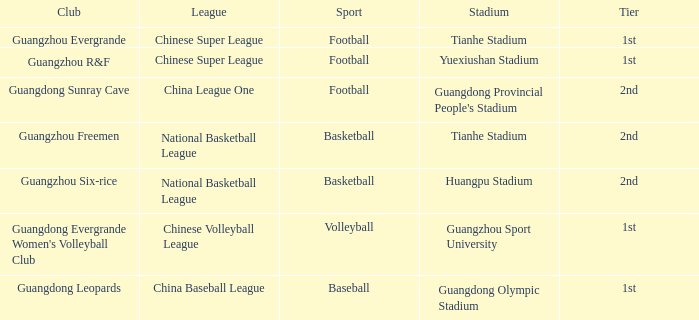Which tier is for football at Tianhe Stadium? 1st. 